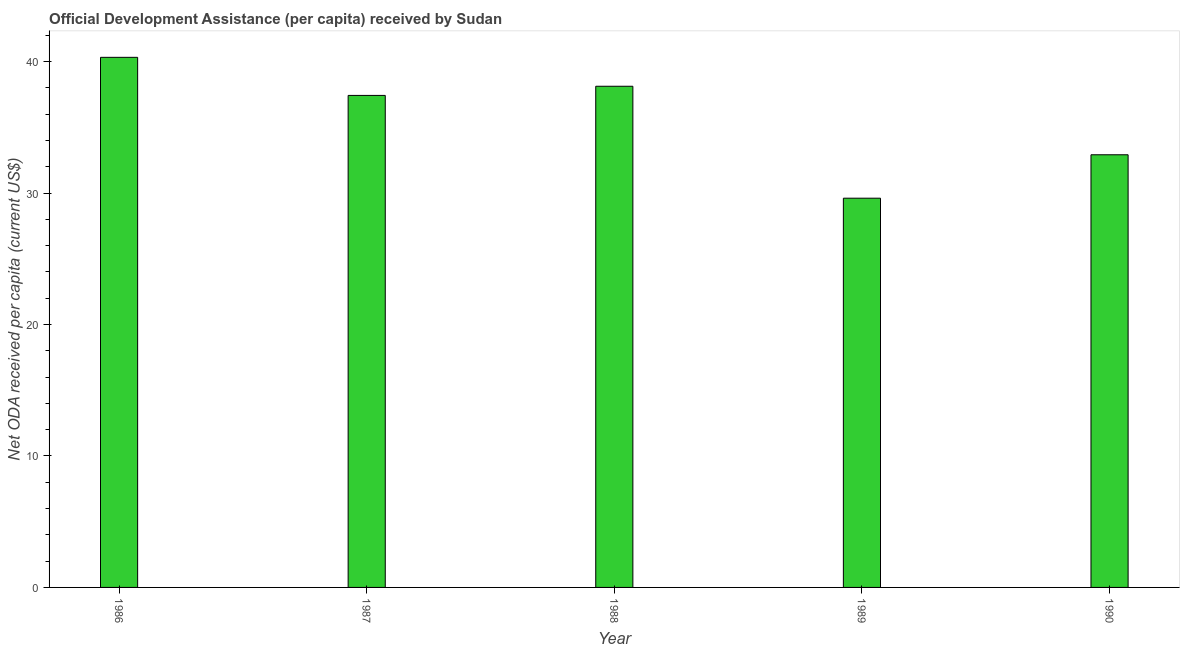Does the graph contain grids?
Make the answer very short. No. What is the title of the graph?
Keep it short and to the point. Official Development Assistance (per capita) received by Sudan. What is the label or title of the Y-axis?
Make the answer very short. Net ODA received per capita (current US$). What is the net oda received per capita in 1986?
Offer a very short reply. 40.33. Across all years, what is the maximum net oda received per capita?
Keep it short and to the point. 40.33. Across all years, what is the minimum net oda received per capita?
Make the answer very short. 29.61. What is the sum of the net oda received per capita?
Your answer should be very brief. 178.41. What is the difference between the net oda received per capita in 1986 and 1989?
Provide a short and direct response. 10.72. What is the average net oda received per capita per year?
Provide a short and direct response. 35.68. What is the median net oda received per capita?
Your response must be concise. 37.43. Do a majority of the years between 1988 and 1989 (inclusive) have net oda received per capita greater than 38 US$?
Keep it short and to the point. No. What is the ratio of the net oda received per capita in 1987 to that in 1990?
Your answer should be compact. 1.14. Is the sum of the net oda received per capita in 1986 and 1990 greater than the maximum net oda received per capita across all years?
Your response must be concise. Yes. What is the difference between the highest and the lowest net oda received per capita?
Your answer should be compact. 10.72. How many bars are there?
Provide a short and direct response. 5. How many years are there in the graph?
Offer a very short reply. 5. What is the difference between two consecutive major ticks on the Y-axis?
Offer a terse response. 10. What is the Net ODA received per capita (current US$) in 1986?
Ensure brevity in your answer.  40.33. What is the Net ODA received per capita (current US$) in 1987?
Make the answer very short. 37.43. What is the Net ODA received per capita (current US$) of 1988?
Your answer should be very brief. 38.13. What is the Net ODA received per capita (current US$) in 1989?
Provide a short and direct response. 29.61. What is the Net ODA received per capita (current US$) of 1990?
Provide a succinct answer. 32.91. What is the difference between the Net ODA received per capita (current US$) in 1986 and 1987?
Make the answer very short. 2.9. What is the difference between the Net ODA received per capita (current US$) in 1986 and 1988?
Your response must be concise. 2.2. What is the difference between the Net ODA received per capita (current US$) in 1986 and 1989?
Your response must be concise. 10.72. What is the difference between the Net ODA received per capita (current US$) in 1986 and 1990?
Make the answer very short. 7.41. What is the difference between the Net ODA received per capita (current US$) in 1987 and 1988?
Give a very brief answer. -0.7. What is the difference between the Net ODA received per capita (current US$) in 1987 and 1989?
Provide a succinct answer. 7.82. What is the difference between the Net ODA received per capita (current US$) in 1987 and 1990?
Make the answer very short. 4.52. What is the difference between the Net ODA received per capita (current US$) in 1988 and 1989?
Offer a terse response. 8.52. What is the difference between the Net ODA received per capita (current US$) in 1988 and 1990?
Make the answer very short. 5.21. What is the difference between the Net ODA received per capita (current US$) in 1989 and 1990?
Give a very brief answer. -3.3. What is the ratio of the Net ODA received per capita (current US$) in 1986 to that in 1987?
Give a very brief answer. 1.08. What is the ratio of the Net ODA received per capita (current US$) in 1986 to that in 1988?
Give a very brief answer. 1.06. What is the ratio of the Net ODA received per capita (current US$) in 1986 to that in 1989?
Your answer should be very brief. 1.36. What is the ratio of the Net ODA received per capita (current US$) in 1986 to that in 1990?
Keep it short and to the point. 1.23. What is the ratio of the Net ODA received per capita (current US$) in 1987 to that in 1988?
Ensure brevity in your answer.  0.98. What is the ratio of the Net ODA received per capita (current US$) in 1987 to that in 1989?
Provide a succinct answer. 1.26. What is the ratio of the Net ODA received per capita (current US$) in 1987 to that in 1990?
Offer a terse response. 1.14. What is the ratio of the Net ODA received per capita (current US$) in 1988 to that in 1989?
Make the answer very short. 1.29. What is the ratio of the Net ODA received per capita (current US$) in 1988 to that in 1990?
Ensure brevity in your answer.  1.16. What is the ratio of the Net ODA received per capita (current US$) in 1989 to that in 1990?
Offer a very short reply. 0.9. 